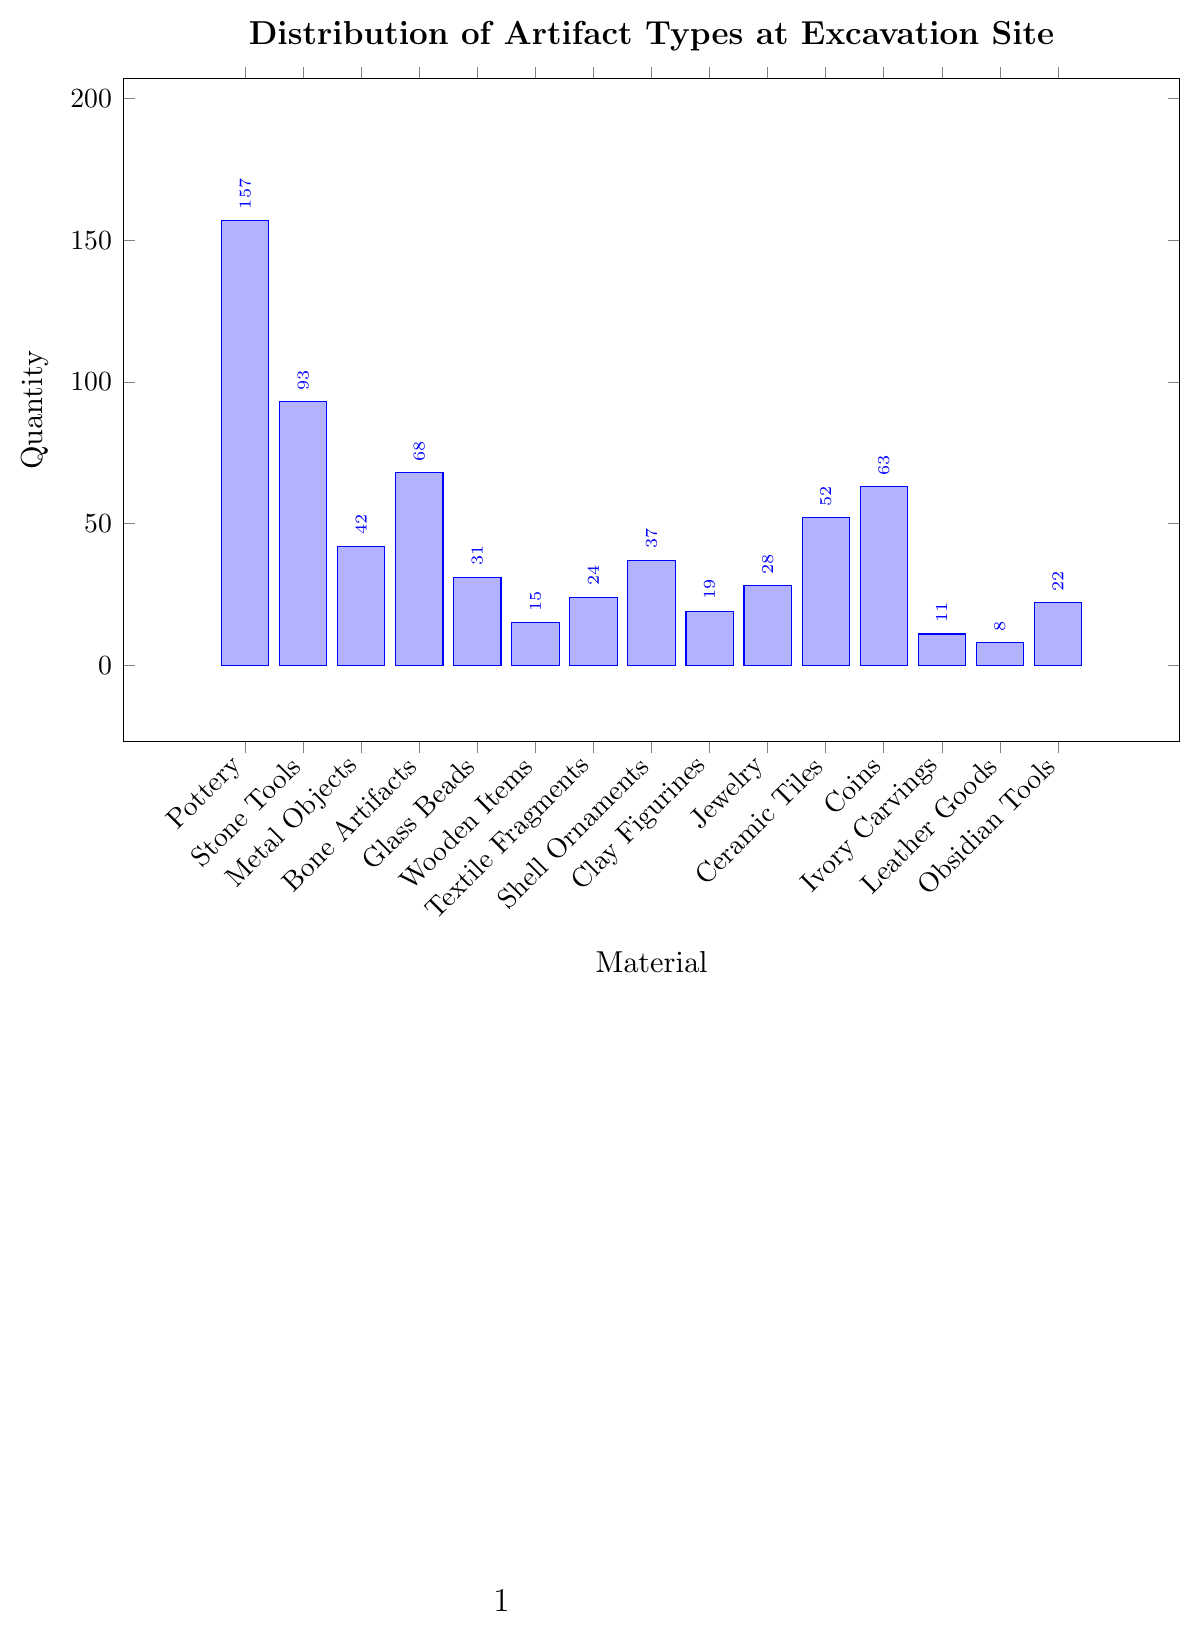Which material has the highest quantity of artifacts? The material with the highest quantity of artifacts can be identified by looking for the tallest bar in the chart. Pottery has a quantity of 157, which is the highest among all materials.
Answer: Pottery Which material has the lowest quantity of artifacts? The material with the lowest quantity of artifacts can be identified by looking for the shortest bar in the chart. Leather Goods has a quantity of 8, which is the lowest among all materials.
Answer: Leather Goods What is the total quantity of artifacts for Stone Tools, Metal Objects, and Bone Artifacts combined? To find the total quantity of artifacts for Stone Tools, Metal Objects, and Bone Artifacts, sum their respective quantities: 93 (Stone Tools) + 42 (Metal Objects) + 68 (Bone Artifacts) = 203.
Answer: 203 Which material quantities are higher: Ceramic Tiles or Coins? To determine which material has a higher quantity, compare the heights of the bars for Ceramic Tiles and Coins. Ceramic Tiles has a quantity of 52, while Coins have a quantity of 63.
Answer: Coins How does the quantity of Glass Beads compare to Ivory Carvings? To compare the quantities of Glass Beads and Ivory Carvings, look at the heights of the respective bars. Glass Beads have a quantity of 31, and Ivory Carvings have a quantity of 11. Glass Beads' quantity is higher.
Answer: Glass Beads What is the average quantity of artifacts for Wooden Items, Textile Fragments, and Shell Ornaments? To find the average quantity, sum the quantities of Wooden Items, Textile Fragments, and Shell Ornaments, then divide by the number of materials. (15 + 24 + 37) / 3 = 76 / 3 ≈ 25.33.
Answer: 25.33 If you combine the quantities of Jewelry, Coins, and Obsidian Tools, what is the result? To combine these quantities, sum the quantities of Jewelry, Coins, and Obsidian Tools. 28 (Jewelry) + 63 (Coins) + 22 (Obsidian Tools) = 113.
Answer: 113 Which material has a more significant quantity difference with Clay Figurines: Pottery or Textile Fragments? Calculate the differences: Pottery (157) - Clay Figurines (19) = 138, and Textile Fragments (24) - Clay Figurines (19) = 5. Pottery has the more significant quantity difference.
Answer: Pottery What is the range of artifact quantities at the excavation site? The range is determined by subtracting the lowest quantity from the highest quantity. Highest is Pottery (157), and lowest is Leather Goods (8). Range = 157 - 8 = 149.
Answer: 149 How many materials have a quantity higher than 50? To determine the number of materials with quantities higher than 50, count the bars exceeding this value. Pottery (157), Stone Tools (93), Bone Artifacts (68), Ceramic Tiles (52), and Coins (63) each have quantities higher than 50.
Answer: 5 